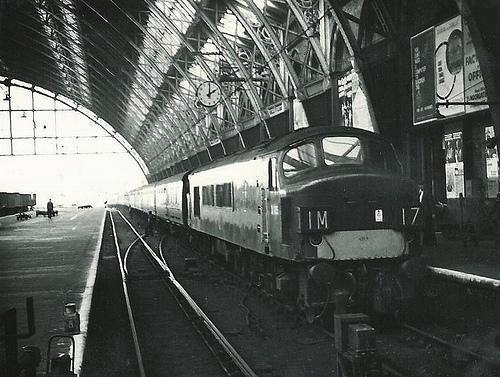How many trains are there?
Give a very brief answer. 1. 